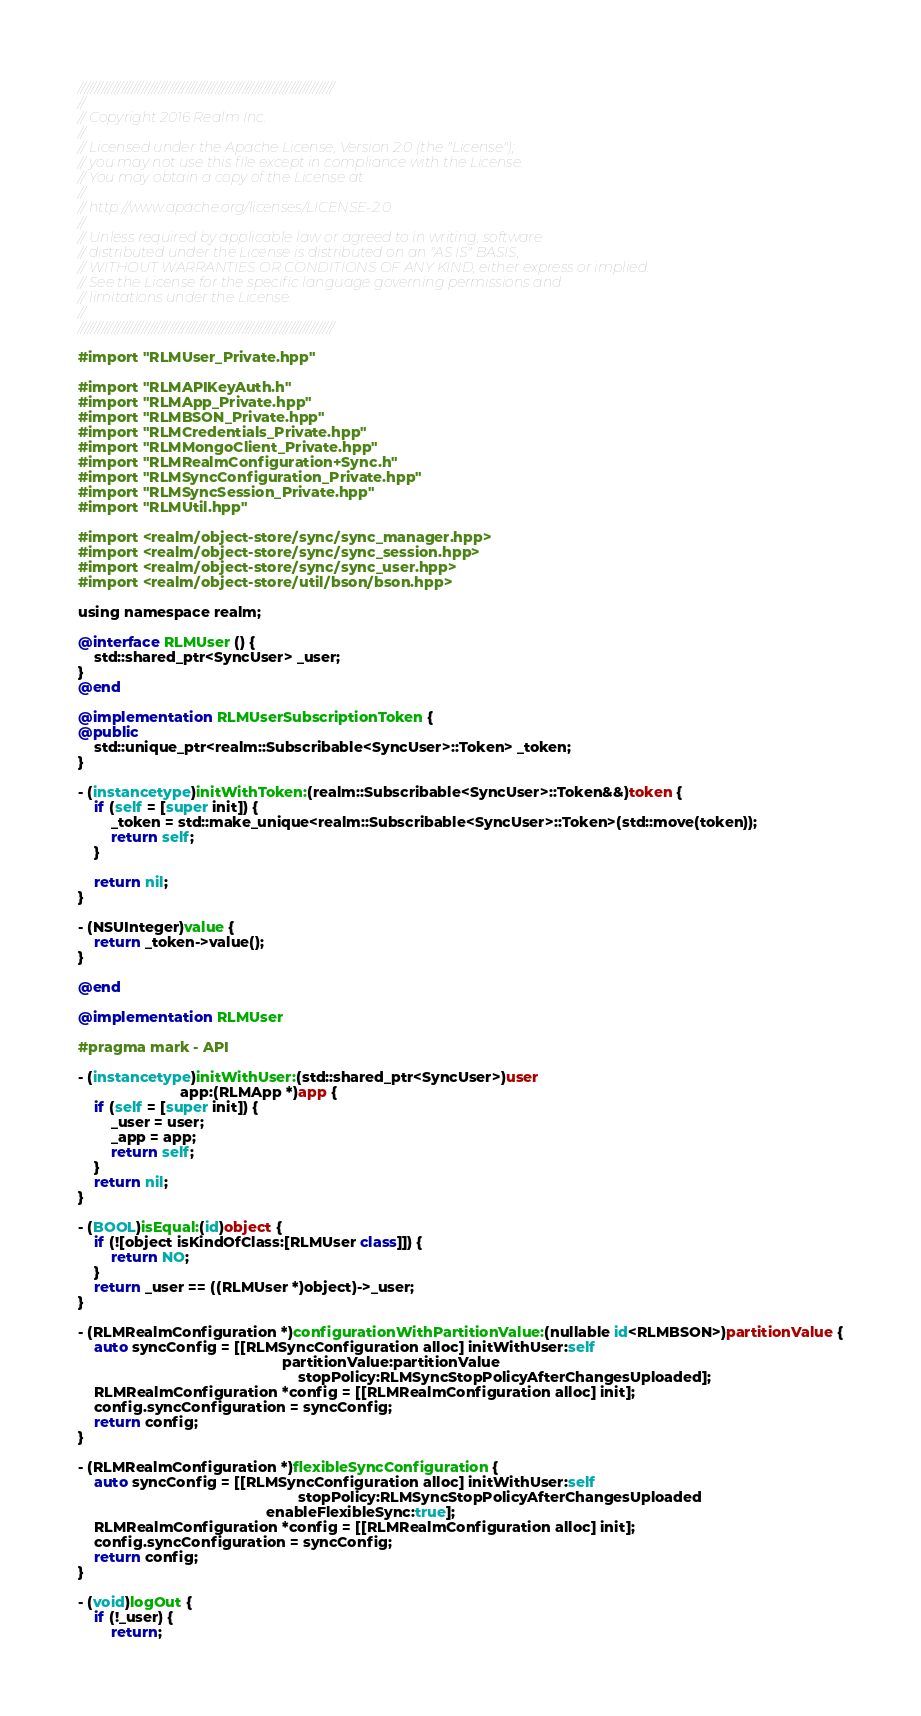Convert code to text. <code><loc_0><loc_0><loc_500><loc_500><_ObjectiveC_>////////////////////////////////////////////////////////////////////////////
//
// Copyright 2016 Realm Inc.
//
// Licensed under the Apache License, Version 2.0 (the "License");
// you may not use this file except in compliance with the License.
// You may obtain a copy of the License at
//
// http://www.apache.org/licenses/LICENSE-2.0
//
// Unless required by applicable law or agreed to in writing, software
// distributed under the License is distributed on an "AS IS" BASIS,
// WITHOUT WARRANTIES OR CONDITIONS OF ANY KIND, either express or implied.
// See the License for the specific language governing permissions and
// limitations under the License.
//
////////////////////////////////////////////////////////////////////////////

#import "RLMUser_Private.hpp"

#import "RLMAPIKeyAuth.h"
#import "RLMApp_Private.hpp"
#import "RLMBSON_Private.hpp"
#import "RLMCredentials_Private.hpp"
#import "RLMMongoClient_Private.hpp"
#import "RLMRealmConfiguration+Sync.h"
#import "RLMSyncConfiguration_Private.hpp"
#import "RLMSyncSession_Private.hpp"
#import "RLMUtil.hpp"

#import <realm/object-store/sync/sync_manager.hpp>
#import <realm/object-store/sync/sync_session.hpp>
#import <realm/object-store/sync/sync_user.hpp>
#import <realm/object-store/util/bson/bson.hpp>

using namespace realm;

@interface RLMUser () {
    std::shared_ptr<SyncUser> _user;
}
@end

@implementation RLMUserSubscriptionToken {
@public
    std::unique_ptr<realm::Subscribable<SyncUser>::Token> _token;
}

- (instancetype)initWithToken:(realm::Subscribable<SyncUser>::Token&&)token {
    if (self = [super init]) {
        _token = std::make_unique<realm::Subscribable<SyncUser>::Token>(std::move(token));
        return self;
    }

    return nil;
}

- (NSUInteger)value {
    return _token->value();
}

@end

@implementation RLMUser

#pragma mark - API

- (instancetype)initWithUser:(std::shared_ptr<SyncUser>)user
                         app:(RLMApp *)app {
    if (self = [super init]) {
        _user = user;
        _app = app;
        return self;
    }
    return nil;
}

- (BOOL)isEqual:(id)object {
    if (![object isKindOfClass:[RLMUser class]]) {
        return NO;
    }
    return _user == ((RLMUser *)object)->_user;
}

- (RLMRealmConfiguration *)configurationWithPartitionValue:(nullable id<RLMBSON>)partitionValue {
    auto syncConfig = [[RLMSyncConfiguration alloc] initWithUser:self
                                                  partitionValue:partitionValue
                                                      stopPolicy:RLMSyncStopPolicyAfterChangesUploaded];
    RLMRealmConfiguration *config = [[RLMRealmConfiguration alloc] init];
    config.syncConfiguration = syncConfig;
    return config;
}

- (RLMRealmConfiguration *)flexibleSyncConfiguration {
    auto syncConfig = [[RLMSyncConfiguration alloc] initWithUser:self
                                                      stopPolicy:RLMSyncStopPolicyAfterChangesUploaded
                                              enableFlexibleSync:true];
    RLMRealmConfiguration *config = [[RLMRealmConfiguration alloc] init];
    config.syncConfiguration = syncConfig;
    return config;
}

- (void)logOut {
    if (!_user) {
        return;</code> 